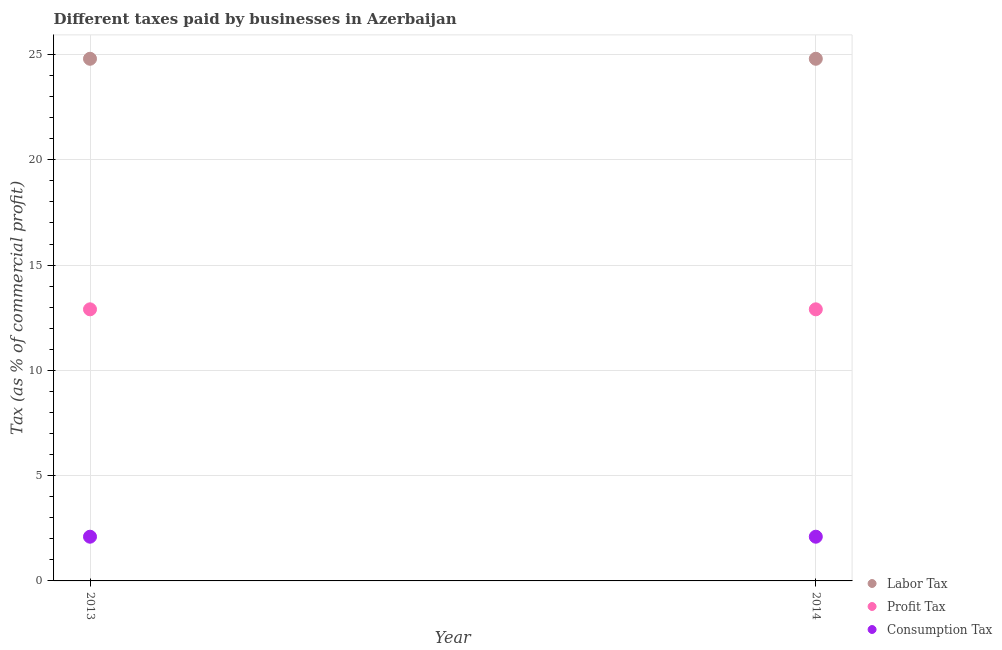How many different coloured dotlines are there?
Ensure brevity in your answer.  3. Is the number of dotlines equal to the number of legend labels?
Provide a short and direct response. Yes. What is the percentage of profit tax in 2014?
Your response must be concise. 12.9. Across all years, what is the maximum percentage of consumption tax?
Your response must be concise. 2.1. Across all years, what is the minimum percentage of labor tax?
Your answer should be compact. 24.8. In which year was the percentage of profit tax maximum?
Your answer should be very brief. 2013. What is the total percentage of labor tax in the graph?
Offer a very short reply. 49.6. What is the difference between the percentage of labor tax in 2013 and that in 2014?
Your answer should be very brief. 0. What is the difference between the percentage of consumption tax in 2014 and the percentage of labor tax in 2013?
Ensure brevity in your answer.  -22.7. What is the average percentage of profit tax per year?
Make the answer very short. 12.9. In the year 2013, what is the difference between the percentage of labor tax and percentage of consumption tax?
Ensure brevity in your answer.  22.7. In how many years, is the percentage of consumption tax greater than the average percentage of consumption tax taken over all years?
Your response must be concise. 0. Is it the case that in every year, the sum of the percentage of labor tax and percentage of profit tax is greater than the percentage of consumption tax?
Offer a terse response. Yes. Is the percentage of profit tax strictly greater than the percentage of labor tax over the years?
Your answer should be very brief. No. How many dotlines are there?
Give a very brief answer. 3. What is the difference between two consecutive major ticks on the Y-axis?
Your answer should be very brief. 5. How many legend labels are there?
Provide a short and direct response. 3. How are the legend labels stacked?
Your answer should be compact. Vertical. What is the title of the graph?
Your answer should be very brief. Different taxes paid by businesses in Azerbaijan. Does "Secondary" appear as one of the legend labels in the graph?
Give a very brief answer. No. What is the label or title of the X-axis?
Make the answer very short. Year. What is the label or title of the Y-axis?
Your answer should be very brief. Tax (as % of commercial profit). What is the Tax (as % of commercial profit) of Labor Tax in 2013?
Provide a short and direct response. 24.8. What is the Tax (as % of commercial profit) of Profit Tax in 2013?
Keep it short and to the point. 12.9. What is the Tax (as % of commercial profit) in Consumption Tax in 2013?
Offer a very short reply. 2.1. What is the Tax (as % of commercial profit) in Labor Tax in 2014?
Keep it short and to the point. 24.8. What is the Tax (as % of commercial profit) of Profit Tax in 2014?
Offer a very short reply. 12.9. What is the Tax (as % of commercial profit) of Consumption Tax in 2014?
Your answer should be compact. 2.1. Across all years, what is the maximum Tax (as % of commercial profit) of Labor Tax?
Give a very brief answer. 24.8. Across all years, what is the maximum Tax (as % of commercial profit) in Profit Tax?
Provide a short and direct response. 12.9. Across all years, what is the maximum Tax (as % of commercial profit) of Consumption Tax?
Your answer should be very brief. 2.1. Across all years, what is the minimum Tax (as % of commercial profit) of Labor Tax?
Offer a terse response. 24.8. Across all years, what is the minimum Tax (as % of commercial profit) of Profit Tax?
Your answer should be very brief. 12.9. Across all years, what is the minimum Tax (as % of commercial profit) in Consumption Tax?
Keep it short and to the point. 2.1. What is the total Tax (as % of commercial profit) of Labor Tax in the graph?
Provide a short and direct response. 49.6. What is the total Tax (as % of commercial profit) in Profit Tax in the graph?
Offer a very short reply. 25.8. What is the difference between the Tax (as % of commercial profit) in Labor Tax in 2013 and the Tax (as % of commercial profit) in Profit Tax in 2014?
Keep it short and to the point. 11.9. What is the difference between the Tax (as % of commercial profit) of Labor Tax in 2013 and the Tax (as % of commercial profit) of Consumption Tax in 2014?
Ensure brevity in your answer.  22.7. What is the average Tax (as % of commercial profit) of Labor Tax per year?
Provide a short and direct response. 24.8. What is the average Tax (as % of commercial profit) of Profit Tax per year?
Give a very brief answer. 12.9. What is the average Tax (as % of commercial profit) in Consumption Tax per year?
Your answer should be very brief. 2.1. In the year 2013, what is the difference between the Tax (as % of commercial profit) of Labor Tax and Tax (as % of commercial profit) of Profit Tax?
Make the answer very short. 11.9. In the year 2013, what is the difference between the Tax (as % of commercial profit) of Labor Tax and Tax (as % of commercial profit) of Consumption Tax?
Offer a terse response. 22.7. In the year 2013, what is the difference between the Tax (as % of commercial profit) of Profit Tax and Tax (as % of commercial profit) of Consumption Tax?
Give a very brief answer. 10.8. In the year 2014, what is the difference between the Tax (as % of commercial profit) in Labor Tax and Tax (as % of commercial profit) in Consumption Tax?
Your answer should be very brief. 22.7. In the year 2014, what is the difference between the Tax (as % of commercial profit) in Profit Tax and Tax (as % of commercial profit) in Consumption Tax?
Keep it short and to the point. 10.8. What is the ratio of the Tax (as % of commercial profit) of Labor Tax in 2013 to that in 2014?
Make the answer very short. 1. What is the ratio of the Tax (as % of commercial profit) in Profit Tax in 2013 to that in 2014?
Make the answer very short. 1. What is the ratio of the Tax (as % of commercial profit) of Consumption Tax in 2013 to that in 2014?
Ensure brevity in your answer.  1. What is the difference between the highest and the lowest Tax (as % of commercial profit) in Consumption Tax?
Your answer should be compact. 0. 